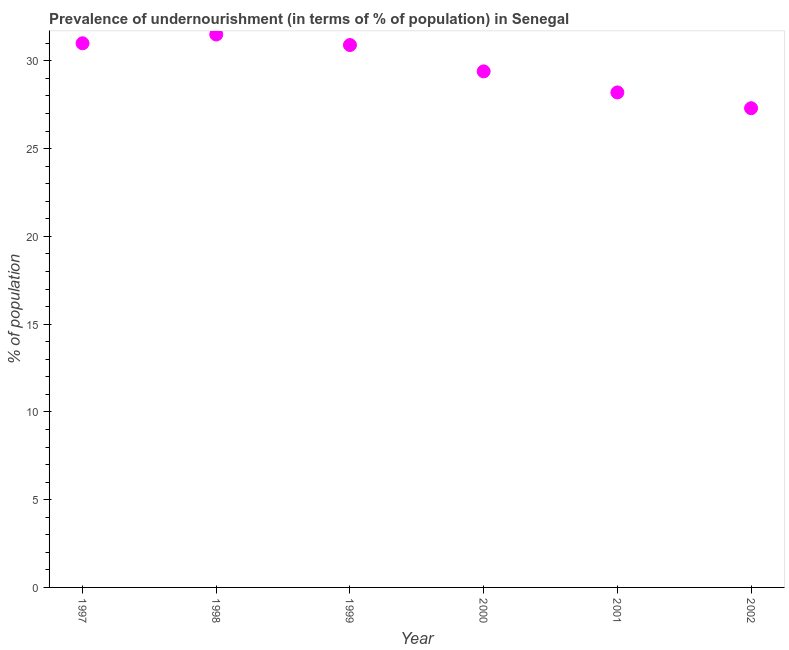Across all years, what is the maximum percentage of undernourished population?
Ensure brevity in your answer.  31.5. Across all years, what is the minimum percentage of undernourished population?
Keep it short and to the point. 27.3. In which year was the percentage of undernourished population maximum?
Provide a succinct answer. 1998. In which year was the percentage of undernourished population minimum?
Give a very brief answer. 2002. What is the sum of the percentage of undernourished population?
Keep it short and to the point. 178.3. What is the difference between the percentage of undernourished population in 1997 and 2001?
Provide a short and direct response. 2.8. What is the average percentage of undernourished population per year?
Ensure brevity in your answer.  29.72. What is the median percentage of undernourished population?
Make the answer very short. 30.15. What is the ratio of the percentage of undernourished population in 1998 to that in 1999?
Offer a very short reply. 1.02. Is the percentage of undernourished population in 1997 less than that in 1999?
Your answer should be compact. No. Is the difference between the percentage of undernourished population in 1997 and 2001 greater than the difference between any two years?
Your answer should be compact. No. What is the difference between the highest and the second highest percentage of undernourished population?
Offer a very short reply. 0.5. Is the sum of the percentage of undernourished population in 1998 and 2000 greater than the maximum percentage of undernourished population across all years?
Make the answer very short. Yes. What is the difference between the highest and the lowest percentage of undernourished population?
Offer a terse response. 4.2. In how many years, is the percentage of undernourished population greater than the average percentage of undernourished population taken over all years?
Make the answer very short. 3. How many dotlines are there?
Provide a succinct answer. 1. How many years are there in the graph?
Your response must be concise. 6. What is the difference between two consecutive major ticks on the Y-axis?
Your answer should be compact. 5. Are the values on the major ticks of Y-axis written in scientific E-notation?
Give a very brief answer. No. Does the graph contain any zero values?
Make the answer very short. No. Does the graph contain grids?
Your answer should be compact. No. What is the title of the graph?
Offer a very short reply. Prevalence of undernourishment (in terms of % of population) in Senegal. What is the label or title of the Y-axis?
Your answer should be compact. % of population. What is the % of population in 1997?
Keep it short and to the point. 31. What is the % of population in 1998?
Give a very brief answer. 31.5. What is the % of population in 1999?
Keep it short and to the point. 30.9. What is the % of population in 2000?
Your answer should be very brief. 29.4. What is the % of population in 2001?
Make the answer very short. 28.2. What is the % of population in 2002?
Offer a very short reply. 27.3. What is the difference between the % of population in 1997 and 1998?
Offer a terse response. -0.5. What is the difference between the % of population in 1997 and 1999?
Provide a succinct answer. 0.1. What is the difference between the % of population in 1997 and 2001?
Offer a very short reply. 2.8. What is the difference between the % of population in 1997 and 2002?
Your response must be concise. 3.7. What is the difference between the % of population in 1998 and 1999?
Make the answer very short. 0.6. What is the difference between the % of population in 1998 and 2000?
Keep it short and to the point. 2.1. What is the difference between the % of population in 1998 and 2001?
Keep it short and to the point. 3.3. What is the difference between the % of population in 1998 and 2002?
Make the answer very short. 4.2. What is the difference between the % of population in 1999 and 2001?
Your response must be concise. 2.7. What is the difference between the % of population in 1999 and 2002?
Provide a short and direct response. 3.6. What is the difference between the % of population in 2000 and 2001?
Keep it short and to the point. 1.2. What is the difference between the % of population in 2000 and 2002?
Provide a succinct answer. 2.1. What is the ratio of the % of population in 1997 to that in 1999?
Provide a short and direct response. 1. What is the ratio of the % of population in 1997 to that in 2000?
Your answer should be compact. 1.05. What is the ratio of the % of population in 1997 to that in 2001?
Your answer should be compact. 1.1. What is the ratio of the % of population in 1997 to that in 2002?
Your response must be concise. 1.14. What is the ratio of the % of population in 1998 to that in 2000?
Ensure brevity in your answer.  1.07. What is the ratio of the % of population in 1998 to that in 2001?
Provide a short and direct response. 1.12. What is the ratio of the % of population in 1998 to that in 2002?
Provide a short and direct response. 1.15. What is the ratio of the % of population in 1999 to that in 2000?
Provide a succinct answer. 1.05. What is the ratio of the % of population in 1999 to that in 2001?
Offer a terse response. 1.1. What is the ratio of the % of population in 1999 to that in 2002?
Ensure brevity in your answer.  1.13. What is the ratio of the % of population in 2000 to that in 2001?
Provide a succinct answer. 1.04. What is the ratio of the % of population in 2000 to that in 2002?
Provide a succinct answer. 1.08. What is the ratio of the % of population in 2001 to that in 2002?
Make the answer very short. 1.03. 